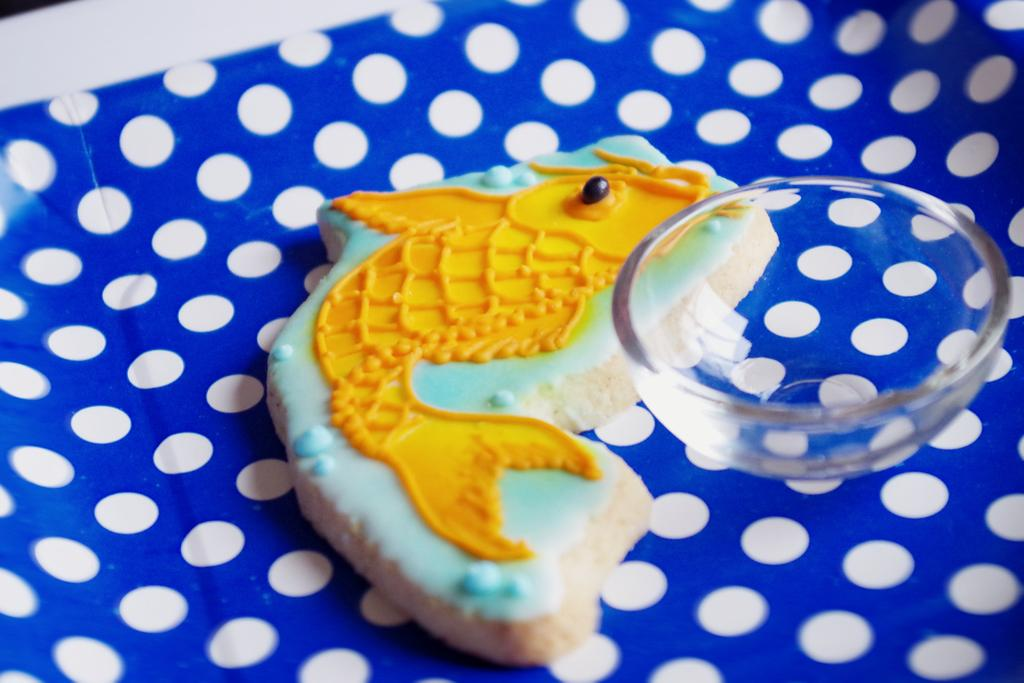What type of cookie is depicted in the image? There is a fish-shaped cookie in the image. What is the bowl used for in the image? The purpose of the bowl is not specified, but it is present in the image. What is the bowl placed on? The bowl is on a paper. What type of invention is being demonstrated in the image? There is no invention being demonstrated in the image; it features a fish-shaped cookie and a bowl on a paper. What color is the chalk used to draw the button in the image? There is no chalk or button present in the image. 